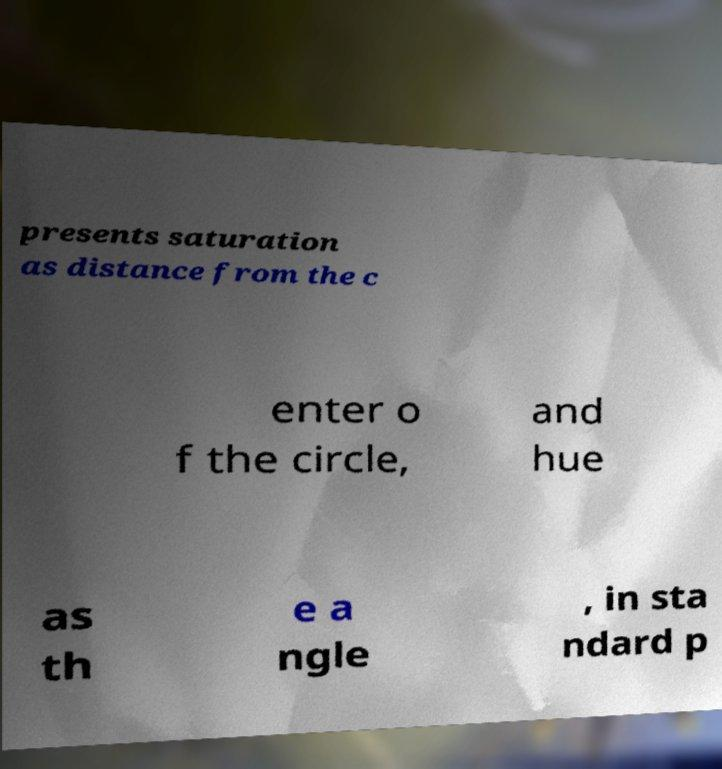There's text embedded in this image that I need extracted. Can you transcribe it verbatim? presents saturation as distance from the c enter o f the circle, and hue as th e a ngle , in sta ndard p 